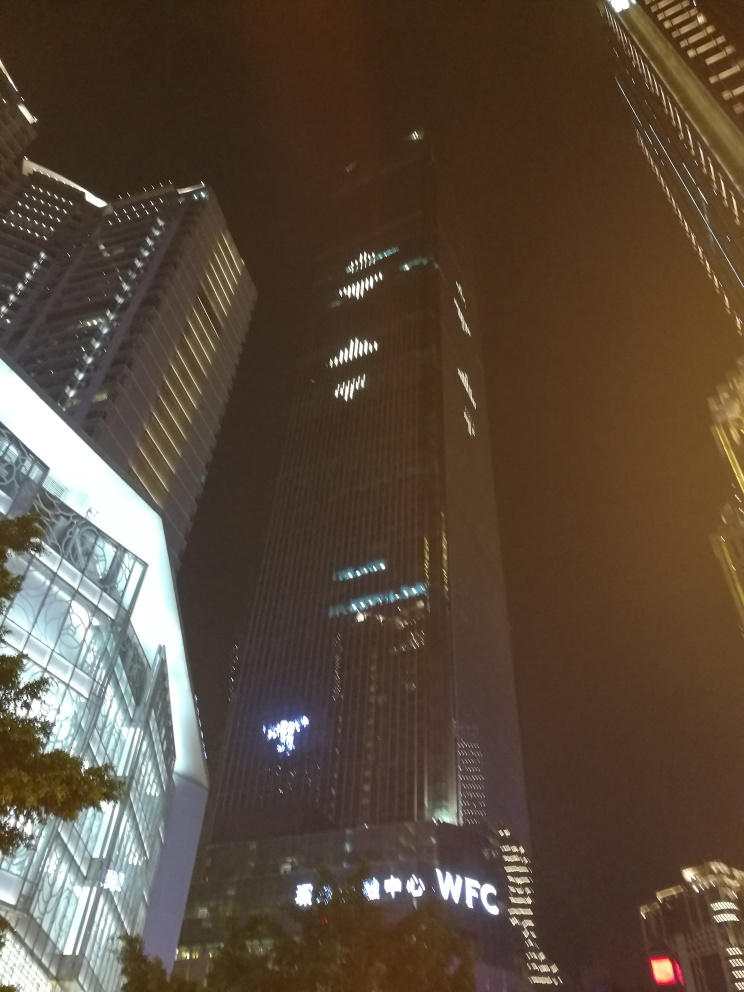What time of day does the image seem to have been taken? The photo appears to have been captured at night, as evidenced by the dark sky and the artificial lighting coming from the buildings' windows and exterior lights. The absence of natural light suggests it is well past sunset. Is there any indication of life or activity in the image? Although there are no people visible in the image, the illuminated windows of the buildings suggest that there may be activity inside. The bright lights against the dark sky also signify the city's active nightlife and the continuous operation of some businesses or facilities within the buildings. 